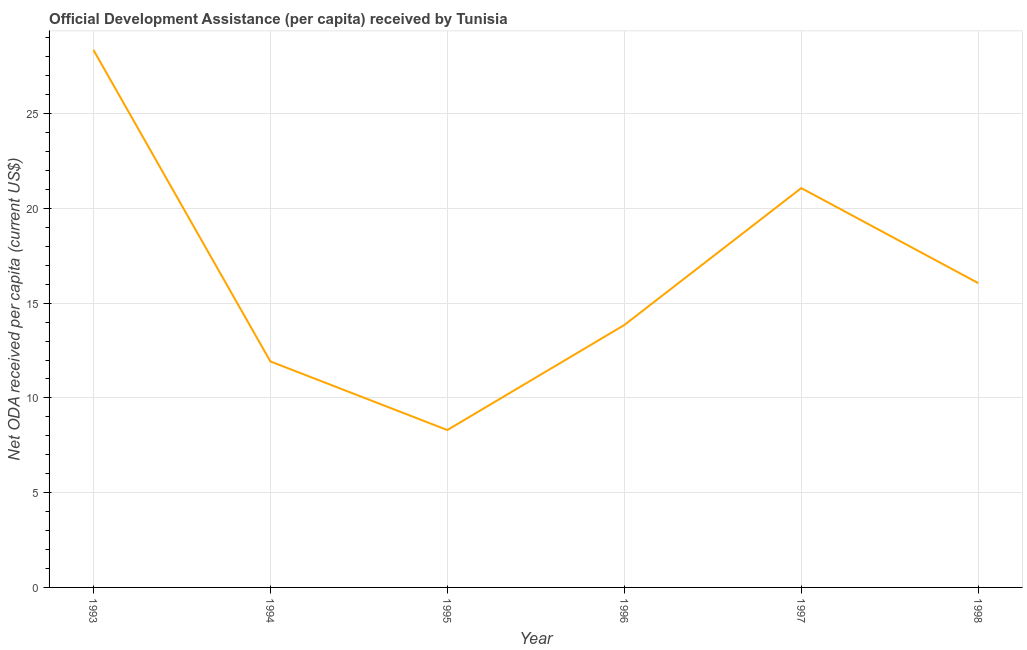What is the net oda received per capita in 1996?
Provide a succinct answer. 13.85. Across all years, what is the maximum net oda received per capita?
Your answer should be very brief. 28.37. Across all years, what is the minimum net oda received per capita?
Keep it short and to the point. 8.31. In which year was the net oda received per capita maximum?
Your answer should be compact. 1993. In which year was the net oda received per capita minimum?
Offer a terse response. 1995. What is the sum of the net oda received per capita?
Offer a terse response. 99.59. What is the difference between the net oda received per capita in 1994 and 1998?
Your response must be concise. -4.13. What is the average net oda received per capita per year?
Provide a succinct answer. 16.6. What is the median net oda received per capita?
Keep it short and to the point. 14.95. In how many years, is the net oda received per capita greater than 11 US$?
Give a very brief answer. 5. What is the ratio of the net oda received per capita in 1993 to that in 1996?
Your answer should be very brief. 2.05. Is the net oda received per capita in 1994 less than that in 1995?
Offer a very short reply. No. Is the difference between the net oda received per capita in 1994 and 1996 greater than the difference between any two years?
Your response must be concise. No. What is the difference between the highest and the second highest net oda received per capita?
Offer a very short reply. 7.3. Is the sum of the net oda received per capita in 1996 and 1998 greater than the maximum net oda received per capita across all years?
Your answer should be very brief. Yes. What is the difference between the highest and the lowest net oda received per capita?
Give a very brief answer. 20.06. In how many years, is the net oda received per capita greater than the average net oda received per capita taken over all years?
Provide a short and direct response. 2. Does the net oda received per capita monotonically increase over the years?
Your response must be concise. No. How many years are there in the graph?
Offer a terse response. 6. Are the values on the major ticks of Y-axis written in scientific E-notation?
Make the answer very short. No. Does the graph contain any zero values?
Ensure brevity in your answer.  No. What is the title of the graph?
Your answer should be compact. Official Development Assistance (per capita) received by Tunisia. What is the label or title of the X-axis?
Your answer should be compact. Year. What is the label or title of the Y-axis?
Your answer should be compact. Net ODA received per capita (current US$). What is the Net ODA received per capita (current US$) in 1993?
Offer a very short reply. 28.37. What is the Net ODA received per capita (current US$) in 1994?
Provide a succinct answer. 11.93. What is the Net ODA received per capita (current US$) of 1995?
Your answer should be compact. 8.31. What is the Net ODA received per capita (current US$) of 1996?
Ensure brevity in your answer.  13.85. What is the Net ODA received per capita (current US$) in 1997?
Your answer should be very brief. 21.07. What is the Net ODA received per capita (current US$) of 1998?
Keep it short and to the point. 16.06. What is the difference between the Net ODA received per capita (current US$) in 1993 and 1994?
Your answer should be compact. 16.44. What is the difference between the Net ODA received per capita (current US$) in 1993 and 1995?
Keep it short and to the point. 20.06. What is the difference between the Net ODA received per capita (current US$) in 1993 and 1996?
Your answer should be compact. 14.52. What is the difference between the Net ODA received per capita (current US$) in 1993 and 1997?
Offer a terse response. 7.3. What is the difference between the Net ODA received per capita (current US$) in 1993 and 1998?
Make the answer very short. 12.31. What is the difference between the Net ODA received per capita (current US$) in 1994 and 1995?
Keep it short and to the point. 3.62. What is the difference between the Net ODA received per capita (current US$) in 1994 and 1996?
Make the answer very short. -1.92. What is the difference between the Net ODA received per capita (current US$) in 1994 and 1997?
Ensure brevity in your answer.  -9.15. What is the difference between the Net ODA received per capita (current US$) in 1994 and 1998?
Provide a succinct answer. -4.13. What is the difference between the Net ODA received per capita (current US$) in 1995 and 1996?
Keep it short and to the point. -5.54. What is the difference between the Net ODA received per capita (current US$) in 1995 and 1997?
Provide a succinct answer. -12.77. What is the difference between the Net ODA received per capita (current US$) in 1995 and 1998?
Your response must be concise. -7.75. What is the difference between the Net ODA received per capita (current US$) in 1996 and 1997?
Your response must be concise. -7.23. What is the difference between the Net ODA received per capita (current US$) in 1996 and 1998?
Your response must be concise. -2.21. What is the difference between the Net ODA received per capita (current US$) in 1997 and 1998?
Make the answer very short. 5.01. What is the ratio of the Net ODA received per capita (current US$) in 1993 to that in 1994?
Offer a terse response. 2.38. What is the ratio of the Net ODA received per capita (current US$) in 1993 to that in 1995?
Offer a terse response. 3.42. What is the ratio of the Net ODA received per capita (current US$) in 1993 to that in 1996?
Keep it short and to the point. 2.05. What is the ratio of the Net ODA received per capita (current US$) in 1993 to that in 1997?
Offer a terse response. 1.35. What is the ratio of the Net ODA received per capita (current US$) in 1993 to that in 1998?
Give a very brief answer. 1.77. What is the ratio of the Net ODA received per capita (current US$) in 1994 to that in 1995?
Keep it short and to the point. 1.44. What is the ratio of the Net ODA received per capita (current US$) in 1994 to that in 1996?
Offer a terse response. 0.86. What is the ratio of the Net ODA received per capita (current US$) in 1994 to that in 1997?
Ensure brevity in your answer.  0.57. What is the ratio of the Net ODA received per capita (current US$) in 1994 to that in 1998?
Ensure brevity in your answer.  0.74. What is the ratio of the Net ODA received per capita (current US$) in 1995 to that in 1997?
Offer a very short reply. 0.39. What is the ratio of the Net ODA received per capita (current US$) in 1995 to that in 1998?
Give a very brief answer. 0.52. What is the ratio of the Net ODA received per capita (current US$) in 1996 to that in 1997?
Your response must be concise. 0.66. What is the ratio of the Net ODA received per capita (current US$) in 1996 to that in 1998?
Give a very brief answer. 0.86. What is the ratio of the Net ODA received per capita (current US$) in 1997 to that in 1998?
Your answer should be compact. 1.31. 